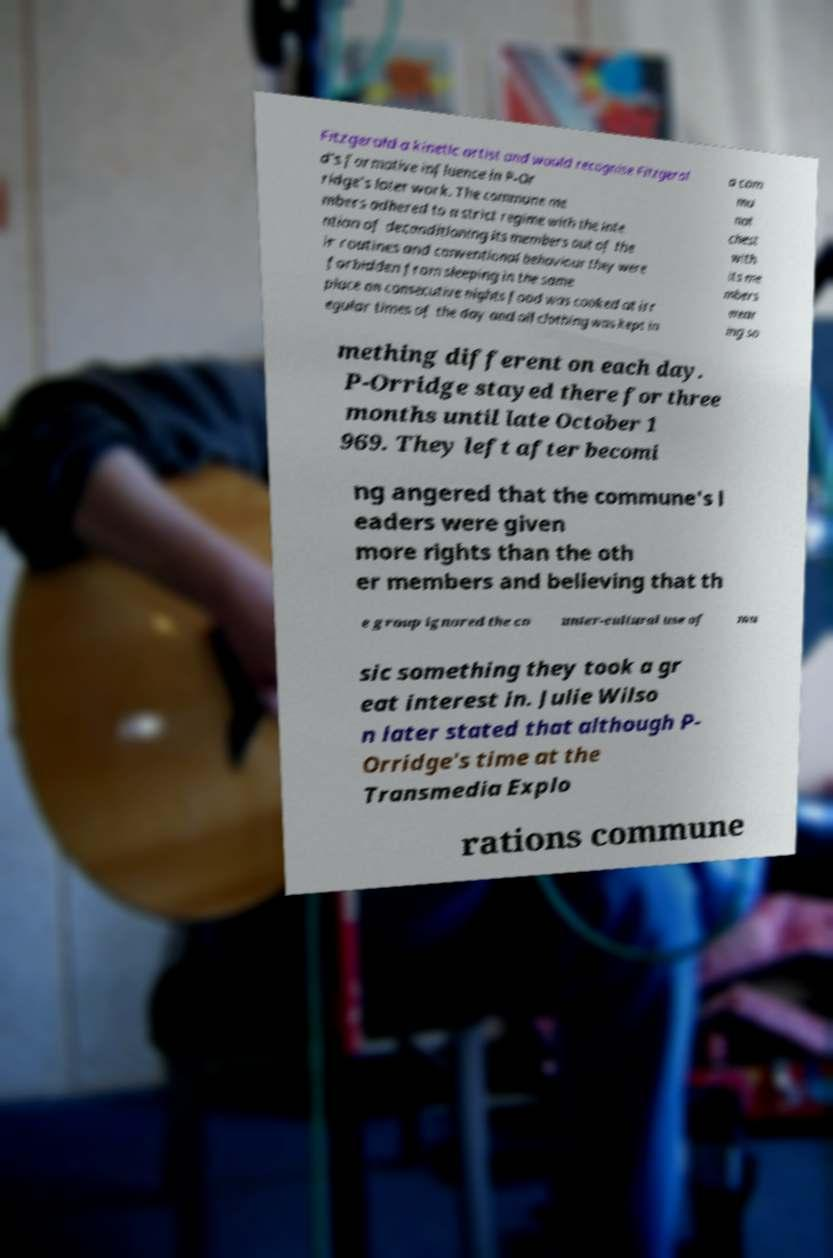Could you extract and type out the text from this image? Fitzgerald a kinetic artist and would recognise Fitzgeral d's formative influence in P-Or ridge's later work. The commune me mbers adhered to a strict regime with the inte ntion of deconditioning its members out of the ir routines and conventional behaviour they were forbidden from sleeping in the same place on consecutive nights food was cooked at irr egular times of the day and all clothing was kept in a com mu nal chest with its me mbers wear ing so mething different on each day. P-Orridge stayed there for three months until late October 1 969. They left after becomi ng angered that the commune's l eaders were given more rights than the oth er members and believing that th e group ignored the co unter-cultural use of mu sic something they took a gr eat interest in. Julie Wilso n later stated that although P- Orridge's time at the Transmedia Explo rations commune 